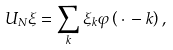Convert formula to latex. <formula><loc_0><loc_0><loc_500><loc_500>U _ { N } \xi = \sum _ { k } \xi _ { k } \varphi \left ( \, \cdot \, - k \right ) ,</formula> 